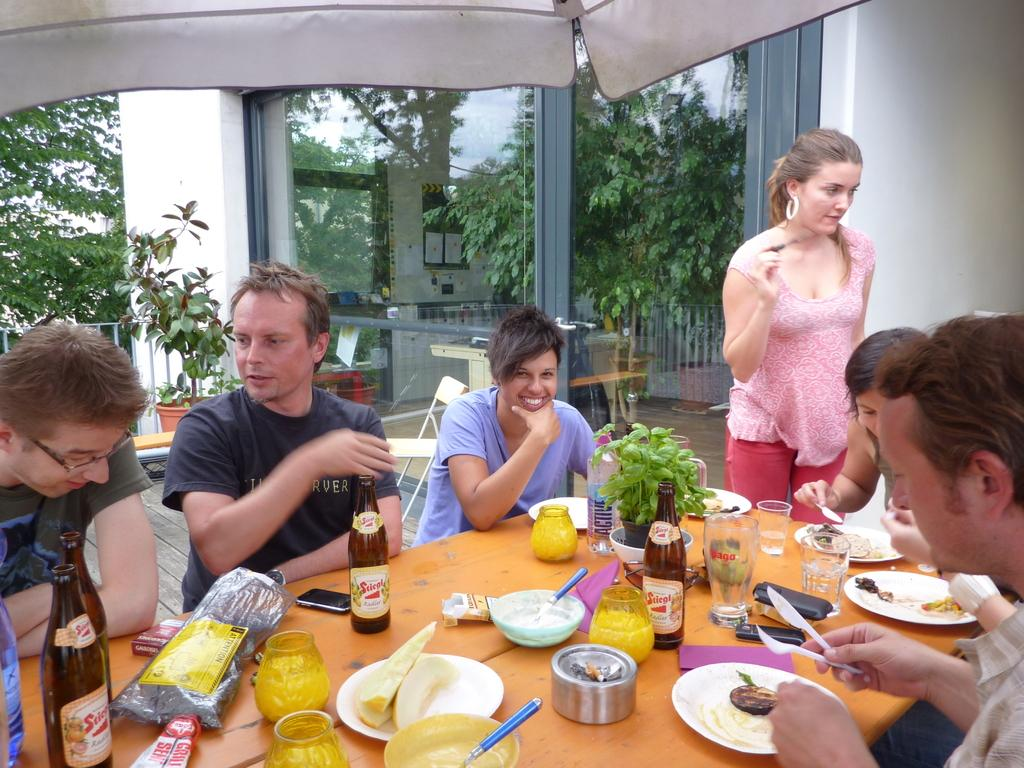What are the people in the image doing? People are sitting on chairs in the image. What objects can be seen on the table? There is a bottle, a glass, a bowl, a spoon, a plate, a phone, and a plant on the table. What type of vegetation is visible in the background? Trees are visible in the background. What type of wood is used to make the office furniture in the image? There is no mention of an office or furniture made of wood in the image. 